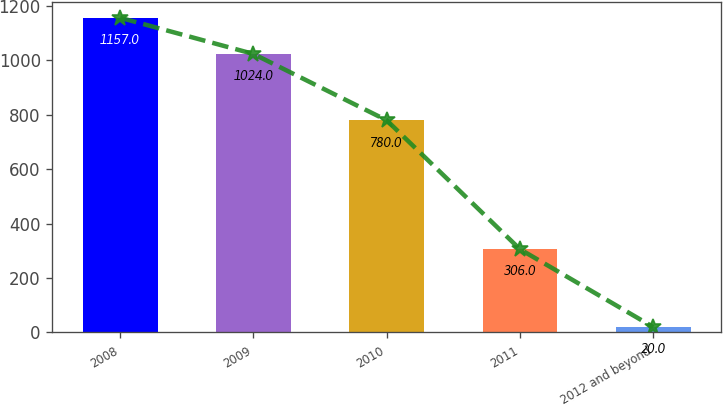Convert chart to OTSL. <chart><loc_0><loc_0><loc_500><loc_500><bar_chart><fcel>2008<fcel>2009<fcel>2010<fcel>2011<fcel>2012 and beyond<nl><fcel>1157<fcel>1024<fcel>780<fcel>306<fcel>20<nl></chart> 